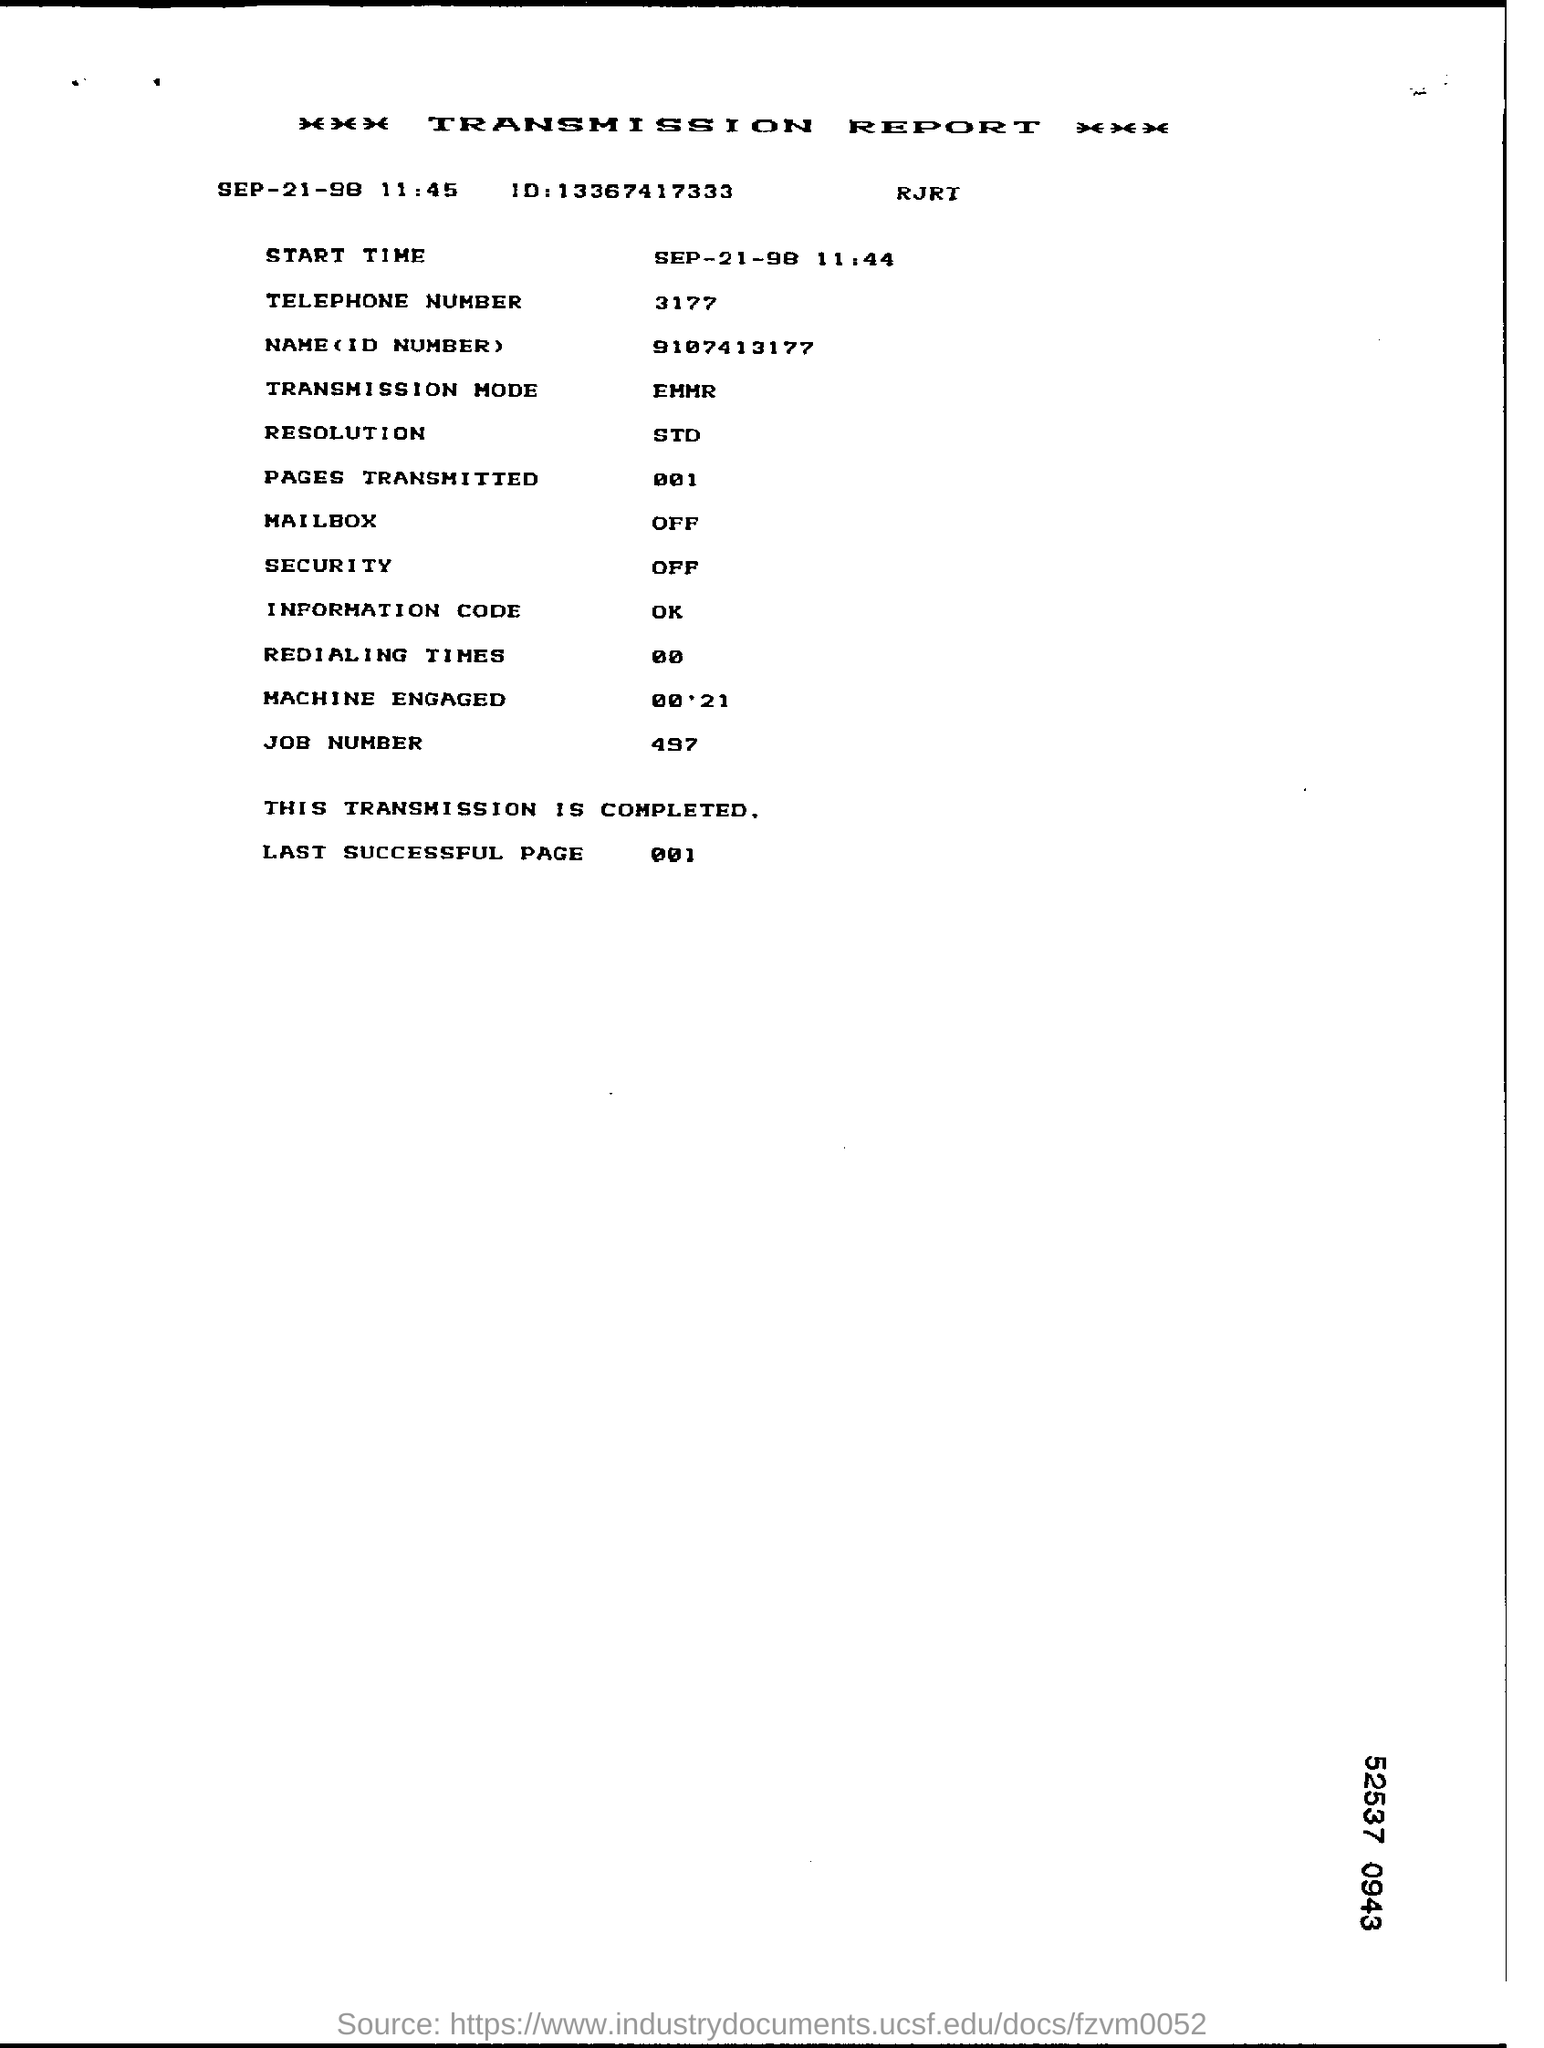what is the last successful page number as per report The last successful page number transmitted according to the report is page number 001. This indicates that the transmission process was complete and successful up to this page. 